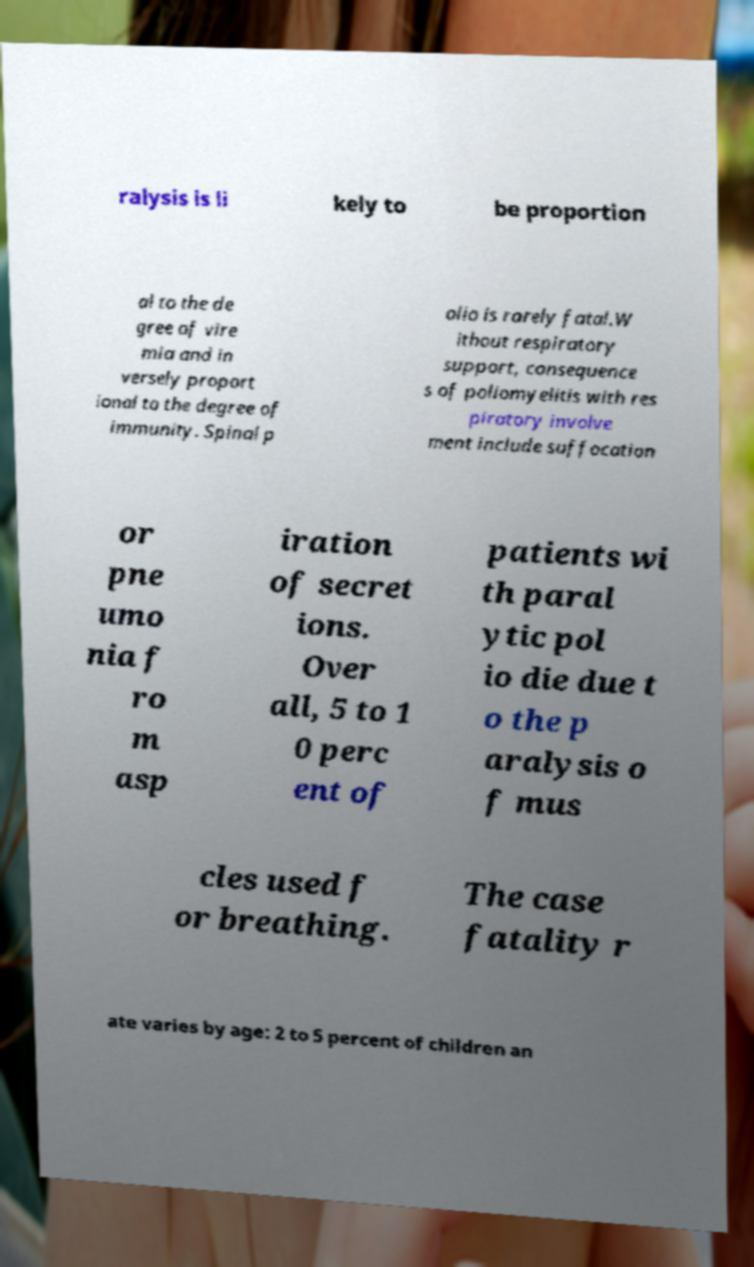Can you accurately transcribe the text from the provided image for me? ralysis is li kely to be proportion al to the de gree of vire mia and in versely proport ional to the degree of immunity. Spinal p olio is rarely fatal.W ithout respiratory support, consequence s of poliomyelitis with res piratory involve ment include suffocation or pne umo nia f ro m asp iration of secret ions. Over all, 5 to 1 0 perc ent of patients wi th paral ytic pol io die due t o the p aralysis o f mus cles used f or breathing. The case fatality r ate varies by age: 2 to 5 percent of children an 